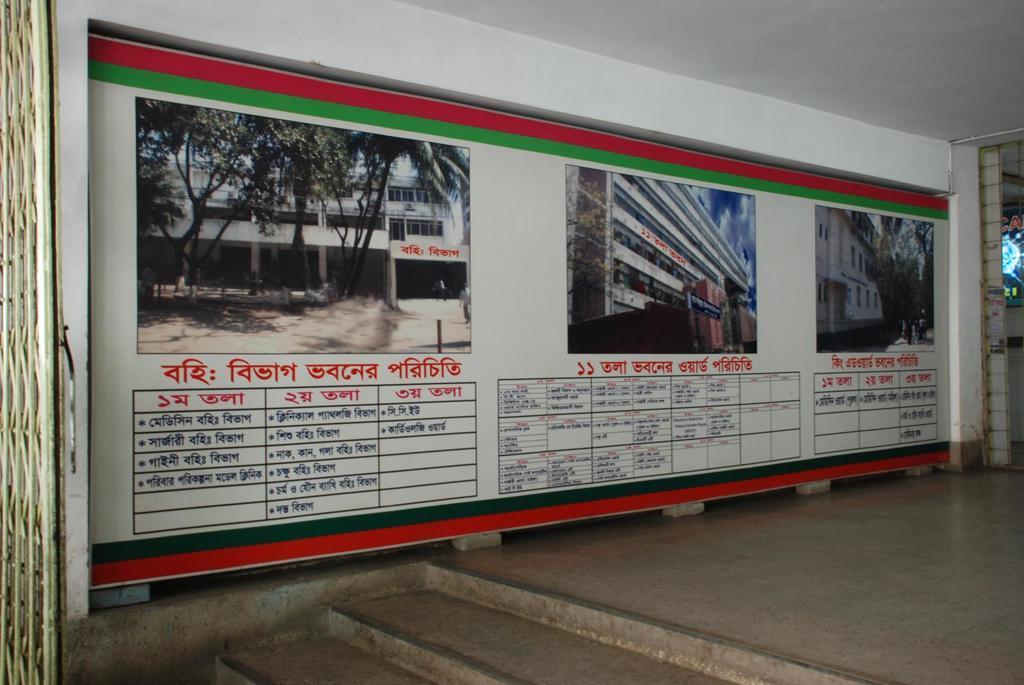In one or two sentences, can you explain what this image depicts? In this picture we can observe three photographs fixed to the wall. We can observe three table in which some information written in them. We can observe red color words on the wall. On the left side there is a gate and we can observe stairs here. 